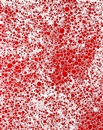What might be an ideal setting for displaying this artwork? This piece would be striking in a minimalist environment where its vibrant color scheme and intricate patterns can dominate the space. A modern art gallery, an avant-garde office, or even a bold, contemporary living room could provide a backdrop that complements its abstract and dynamic nature. The artwork's ability to grab attention would make it a centerpiece in any setting that appreciates bold expressions. 